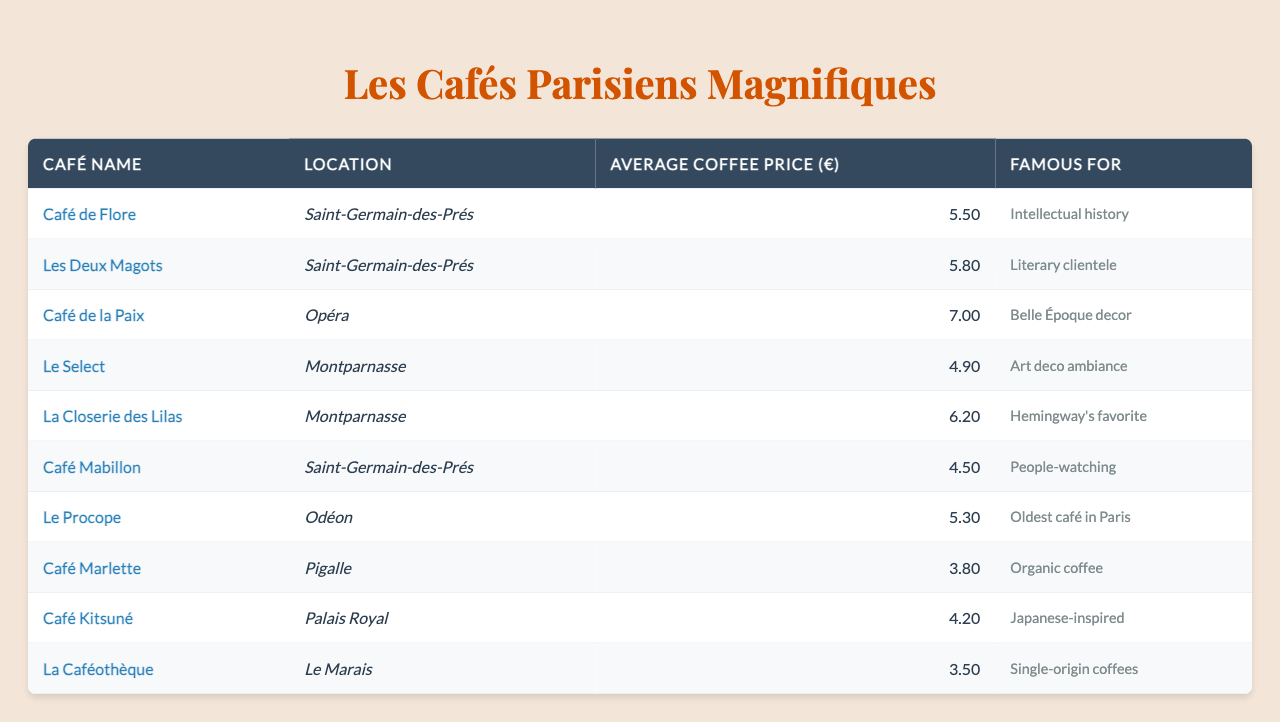What is the average coffee price at Café de la Paix? The table shows that the average coffee price at Café de la Paix is listed as €7.00.
Answer: €7.00 Which café has the lowest average coffee price? Looking at the average coffee prices listed in the table, Café Marlette has the lowest price at €3.80.
Answer: Café Marlette Is La Closerie des Lilas more expensive than Les Deux Magots? The average coffee price at La Closerie des Lilas is €6.20, while at Les Deux Magots it is €5.80. Since €6.20 is greater than €5.80, La Closerie des Lilas is indeed more expensive.
Answer: Yes What is the average coffee price of the cafés located in Montparnasse? The cafés in Montparnasse listed are Le Select (€4.90) and La Closerie des Lilas (€6.20). To find the average: (4.90 + 6.20) / 2 = 11.10 / 2 = €5.55.
Answer: €5.55 How many cafés are noted for their literary or intellectual clientele? From the table, Café de Flore is known for intellectual history and Les Deux Magots for literary clientele, which totals to 2 cafés.
Answer: 2 Which café is famous for its organic coffee, and how much does a coffee cost there? The café famous for organic coffee is Café Marlette, and the average coffee price is €3.80 as listed in the table.
Answer: Café Marlette, €3.80 Are there any cafés located in Saint-Germain-des-Prés? Yes, the table shows three cafés located in Saint-Germain-des-Prés: Café de Flore, Les Deux Magots, and Café Mabillon.
Answer: Yes What is the price difference between the most expensive café and the least expensive café? The most expensive café, Café de la Paix, has a price of €7.00, while the least expensive, La Caféothèque, has a price of €3.50. The difference is €7.00 - €3.50 = €3.50.
Answer: €3.50 In which location can you find the café that has been labeled the oldest café in Paris? According to the table, Le Procope, which is known as the oldest café in Paris, is located in Odéon.
Answer: Odéon Which two cafés are located in Saint-Germain-des-Prés, and what are they known for? The cafés in Saint-Germain-des-Prés are Café de Flore (known for intellectual history) and Les Deux Magots (known for literary clientele).
Answer: Café de Flore and Les Deux Magots 